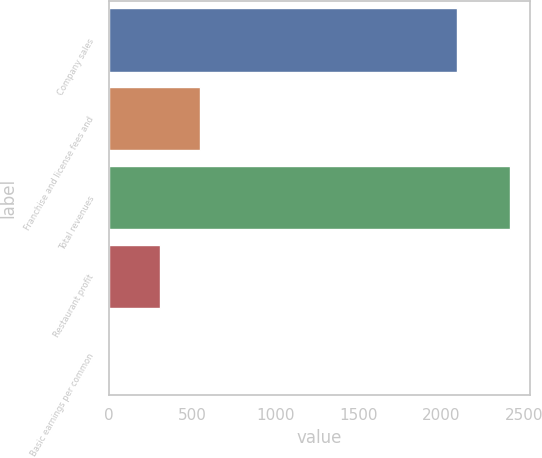Convert chart. <chart><loc_0><loc_0><loc_500><loc_500><bar_chart><fcel>Company sales<fcel>Franchise and license fees and<fcel>Total revenues<fcel>Restaurant profit<fcel>Basic earnings per common<nl><fcel>2094<fcel>549.25<fcel>2413<fcel>308<fcel>0.52<nl></chart> 